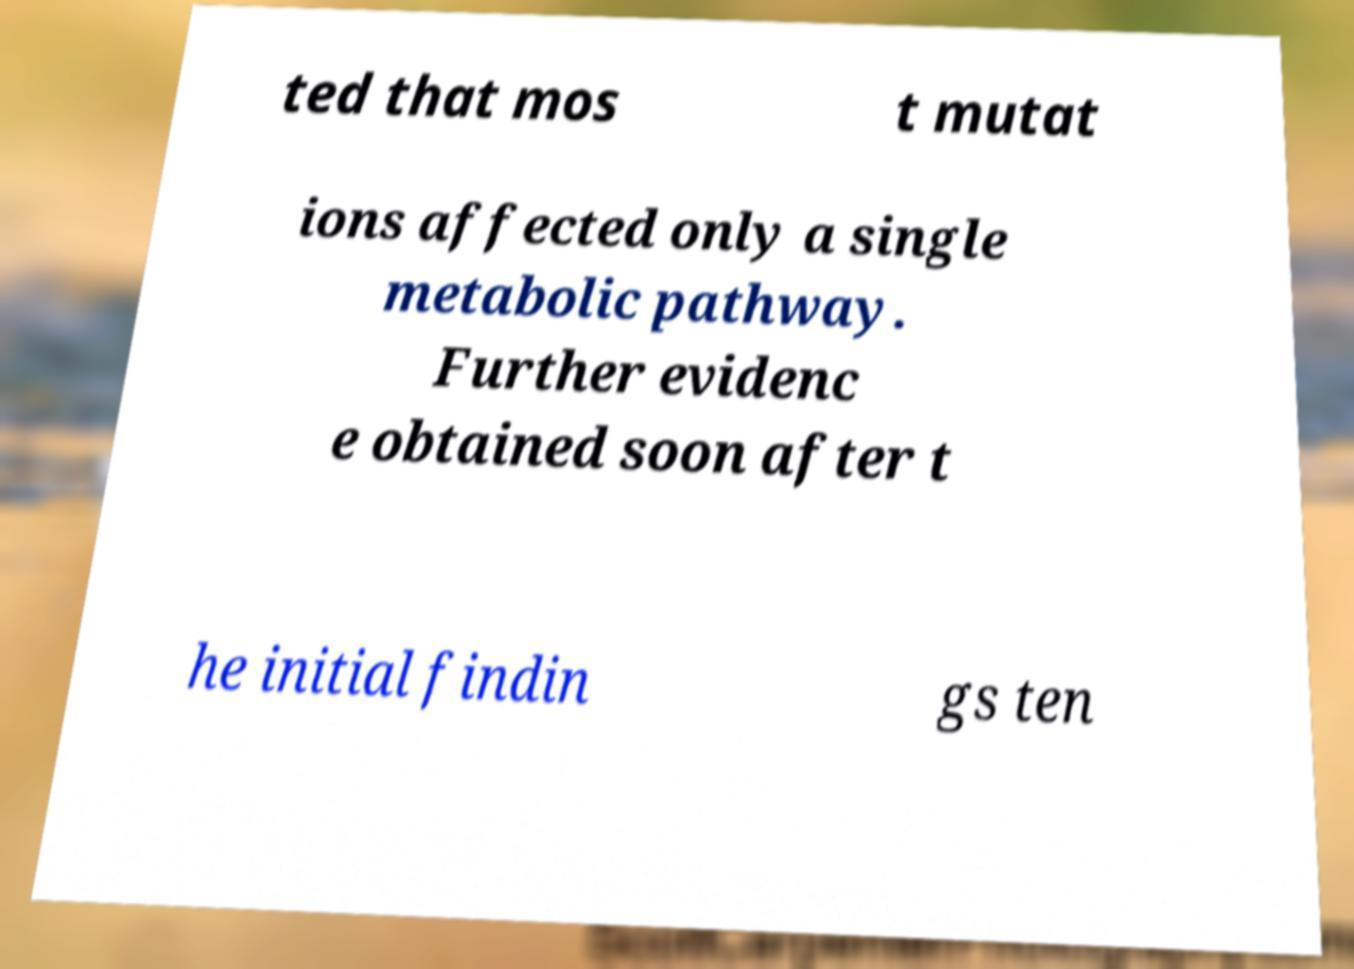What messages or text are displayed in this image? I need them in a readable, typed format. ted that mos t mutat ions affected only a single metabolic pathway. Further evidenc e obtained soon after t he initial findin gs ten 